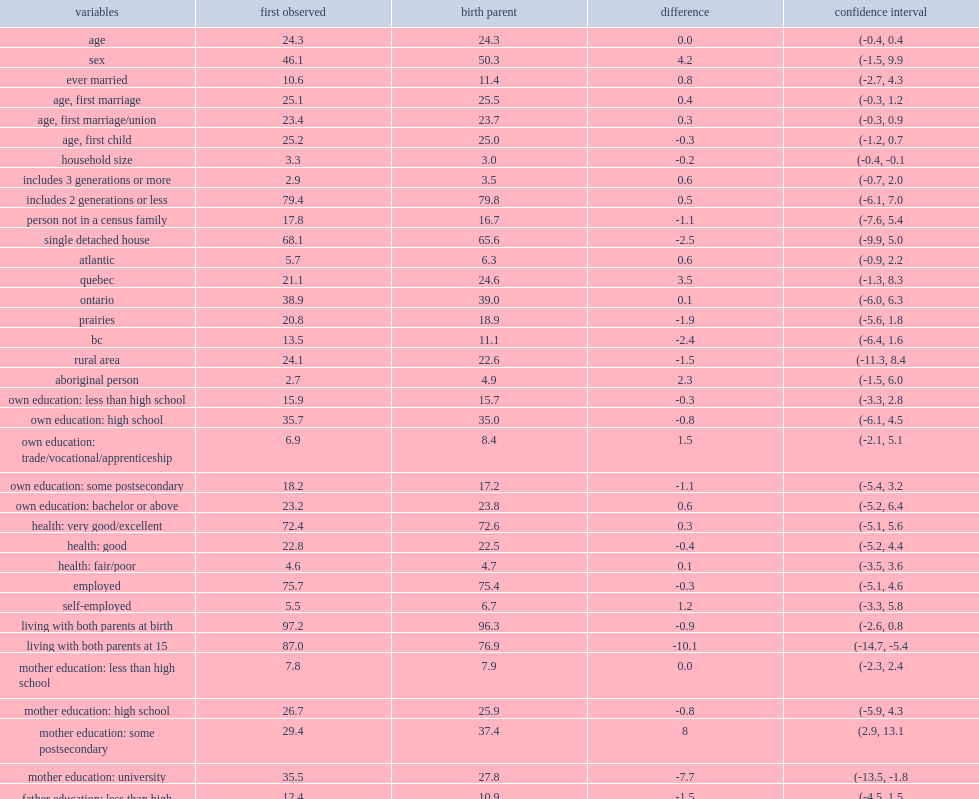How many percentage points are mothers of respondents for whom a birth parent could be found in the tax data less likely to have a university degree? 7.7. How many percentage points are respondents with a birth parent more likely to be canadian born with canadian-born parents? 11.7. 